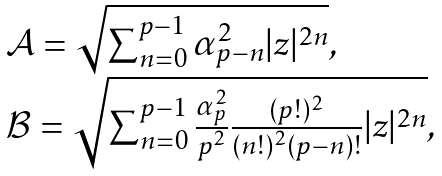<formula> <loc_0><loc_0><loc_500><loc_500>\begin{array} { l } { \mathcal { A } } = \sqrt { \sum _ { n = 0 } ^ { p - 1 } \alpha _ { p - n } ^ { 2 } | z | ^ { 2 n } } , \\ { \mathcal { B } } = \sqrt { \sum _ { n = 0 } ^ { p - 1 } \frac { \alpha _ { p } ^ { 2 } } { p ^ { 2 } } \frac { ( p ! ) ^ { 2 } } { ( n ! ) ^ { 2 } ( p - n ) ! } | z | ^ { 2 n } } , \end{array}</formula> 